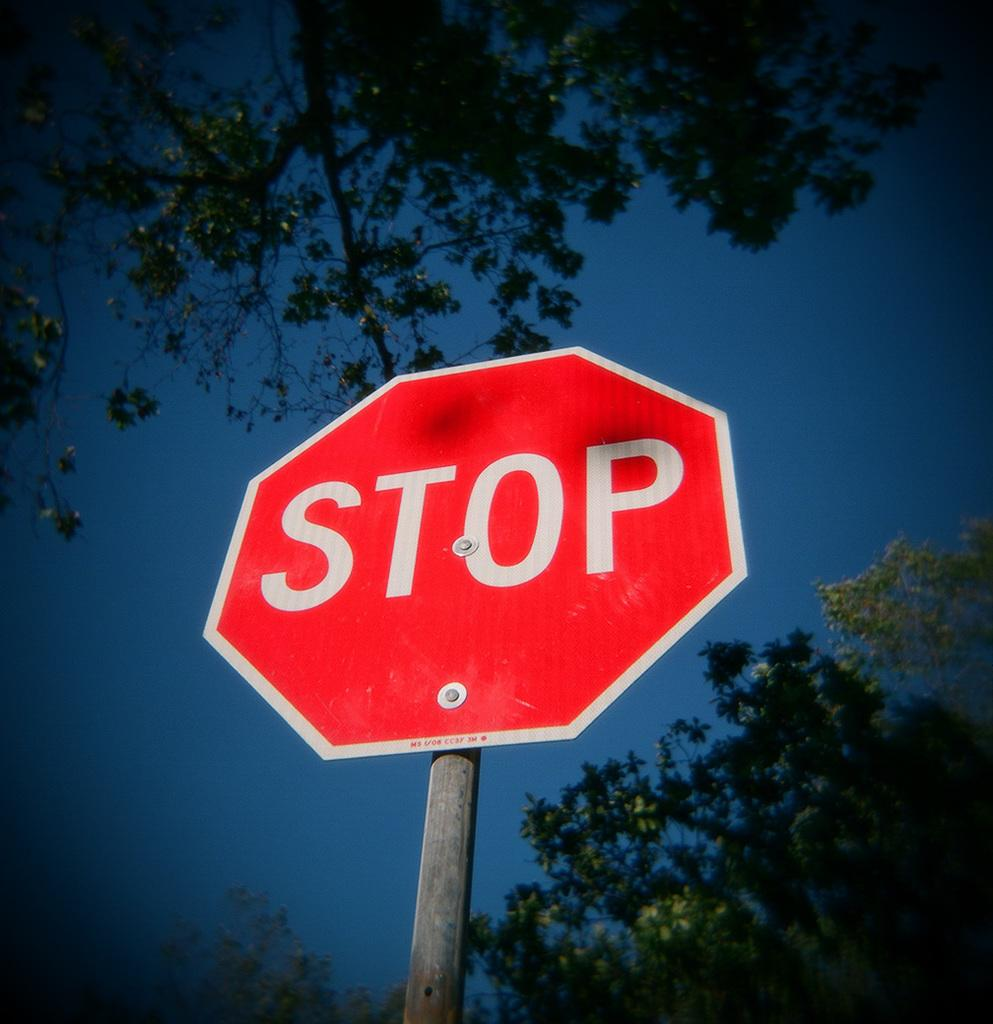<image>
Present a compact description of the photo's key features. A bright red STOP sign in front of a sky background. 